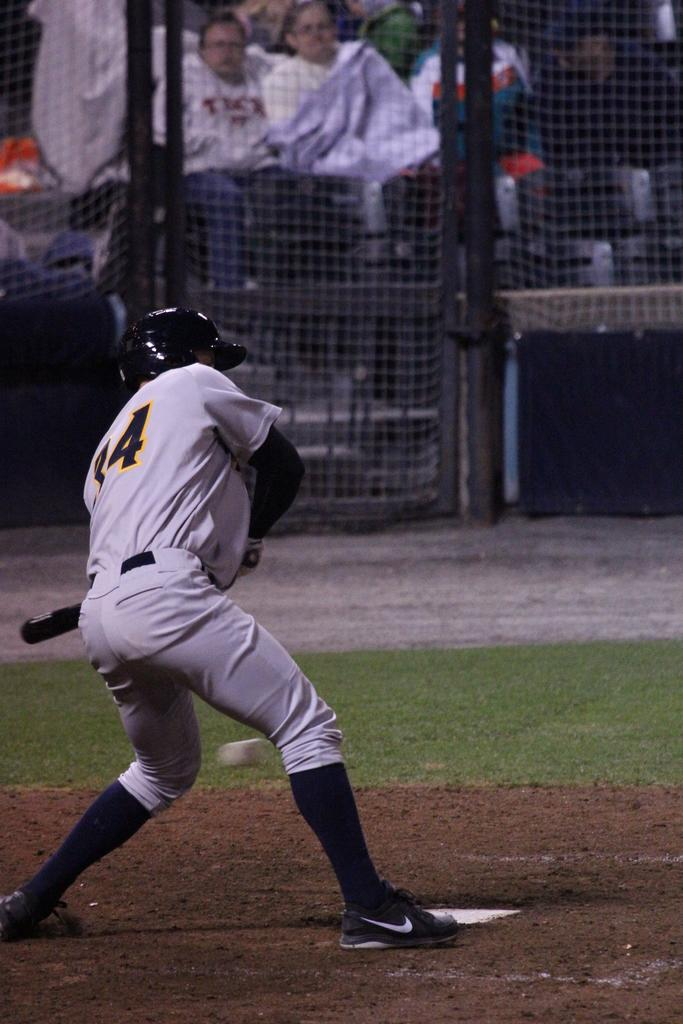Provide a one-sentence caption for the provided image. A baseball player wearing a jersey with the number 34 is about to hit a ball. 